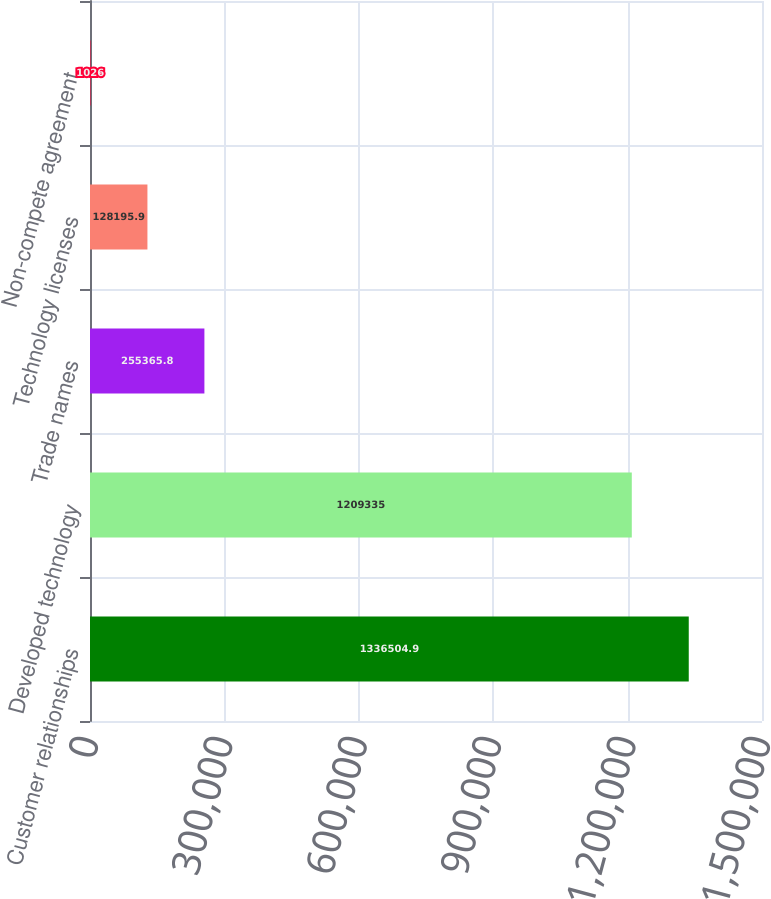Convert chart. <chart><loc_0><loc_0><loc_500><loc_500><bar_chart><fcel>Customer relationships<fcel>Developed technology<fcel>Trade names<fcel>Technology licenses<fcel>Non-compete agreement<nl><fcel>1.3365e+06<fcel>1.20934e+06<fcel>255366<fcel>128196<fcel>1026<nl></chart> 